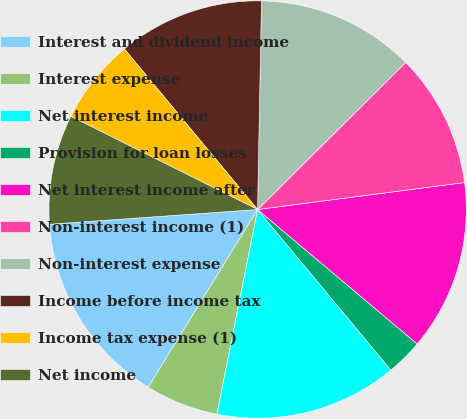Convert chart. <chart><loc_0><loc_0><loc_500><loc_500><pie_chart><fcel>Interest and dividend income<fcel>Interest expense<fcel>Net interest income<fcel>Provision for loan losses<fcel>Net interest income after<fcel>Non-interest income (1)<fcel>Non-interest expense<fcel>Income before income tax<fcel>Income tax expense (1)<fcel>Net income<nl><fcel>15.09%<fcel>5.66%<fcel>14.15%<fcel>2.83%<fcel>13.21%<fcel>10.38%<fcel>12.26%<fcel>11.32%<fcel>6.61%<fcel>8.49%<nl></chart> 